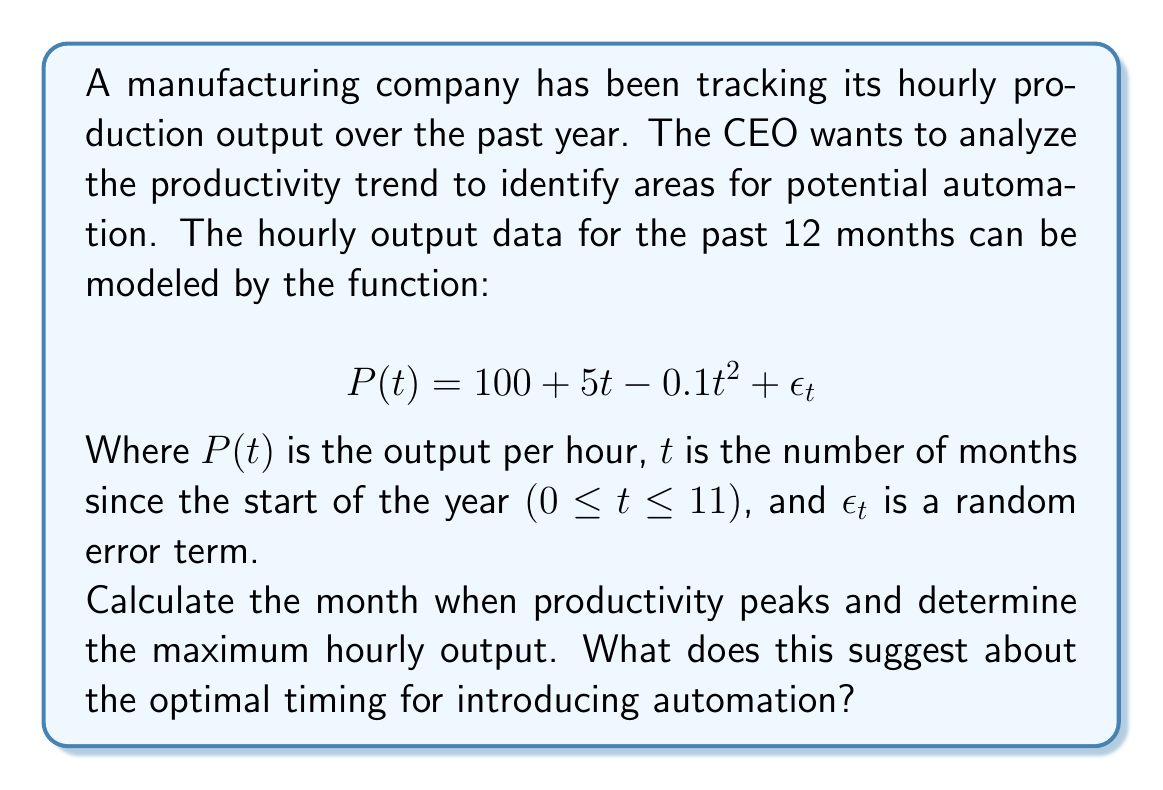Show me your answer to this math problem. To solve this problem, we need to follow these steps:

1. Identify the deterministic part of the time series model:
   $$P(t) = 100 + 5t - 0.1t^2$$

2. Find the derivative of P(t) with respect to t:
   $$\frac{dP}{dt} = 5 - 0.2t$$

3. Set the derivative equal to zero and solve for t to find the peak:
   $$5 - 0.2t = 0$$
   $$0.2t = 5$$
   $$t = 25$$

4. Since t is constrained to 0 ≤ t ≤ 11, the peak occurs at t = 11 (the last month of the year).

5. Calculate the maximum hourly output by plugging t = 11 into the original function:
   $$P(11) = 100 + 5(11) - 0.1(11)^2$$
   $$= 100 + 55 - 12.1$$
   $$= 142.9$$

This analysis suggests that productivity continues to increase throughout the year, peaking in the final month. The maximum hourly output is approximately 143 units.

For the CEO focused on minimizing union influence and improving efficiency, this trend indicates that the optimal time to introduce automation would be after the 11th month. At this point, productivity has reached its peak, and implementing automation could help maintain or exceed this level of output while potentially reducing labor costs and union influence.
Answer: The productivity peaks in the 11th month (t = 11) with a maximum hourly output of approximately 143 units. This suggests that the optimal timing for introducing automation would be after the 11th month to capitalize on the peak productivity and potentially maintain or exceed this level of output while reducing labor dependency. 